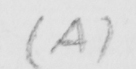Can you tell me what this handwritten text says? ( A ) 